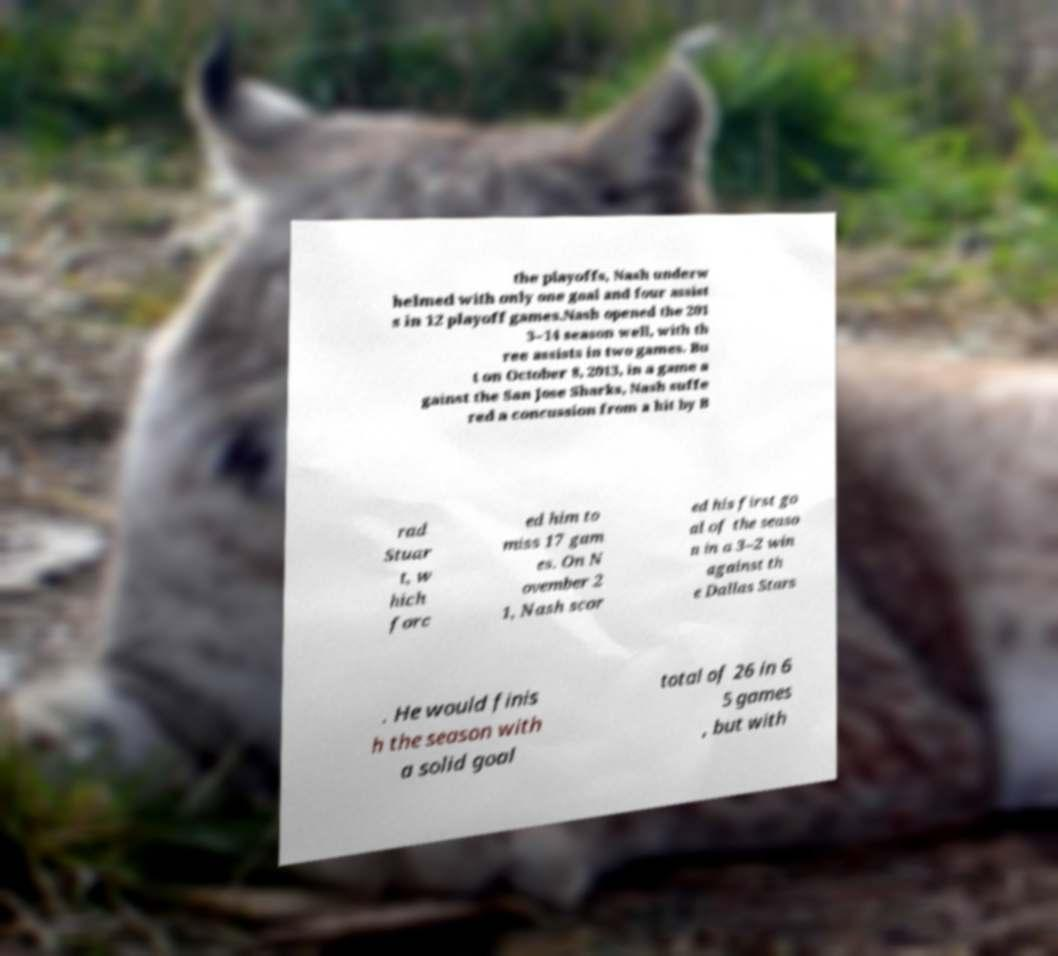Could you assist in decoding the text presented in this image and type it out clearly? the playoffs, Nash underw helmed with only one goal and four assist s in 12 playoff games.Nash opened the 201 3–14 season well, with th ree assists in two games. Bu t on October 8, 2013, in a game a gainst the San Jose Sharks, Nash suffe red a concussion from a hit by B rad Stuar t, w hich forc ed him to miss 17 gam es. On N ovember 2 1, Nash scor ed his first go al of the seaso n in a 3–2 win against th e Dallas Stars . He would finis h the season with a solid goal total of 26 in 6 5 games , but with 